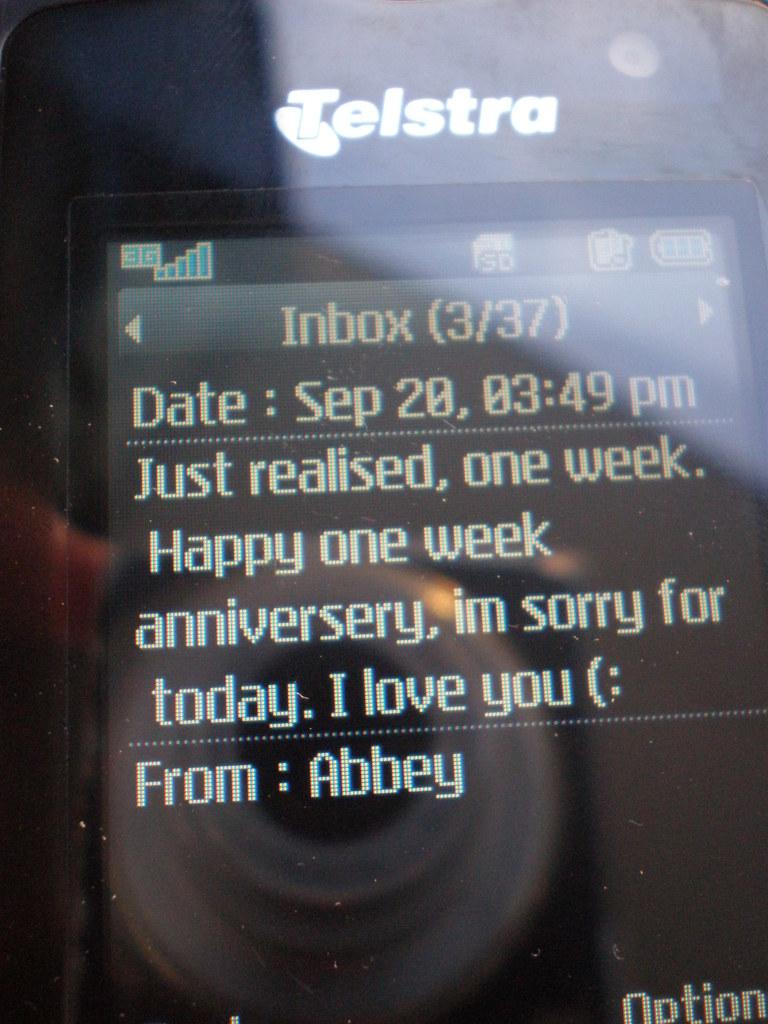<image>
Provide a brief description of the given image. A picture of a cellphone screen from Telstra that reads Just realised, one week. 